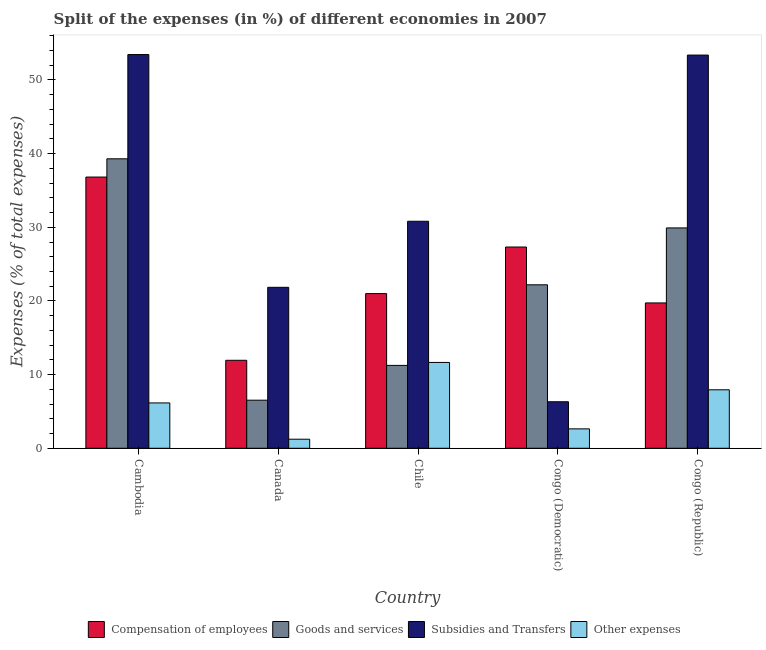How many groups of bars are there?
Make the answer very short. 5. Are the number of bars on each tick of the X-axis equal?
Provide a short and direct response. Yes. How many bars are there on the 4th tick from the left?
Your answer should be compact. 4. What is the label of the 5th group of bars from the left?
Ensure brevity in your answer.  Congo (Republic). In how many cases, is the number of bars for a given country not equal to the number of legend labels?
Your answer should be very brief. 0. What is the percentage of amount spent on subsidies in Congo (Democratic)?
Offer a terse response. 6.32. Across all countries, what is the maximum percentage of amount spent on other expenses?
Ensure brevity in your answer.  11.65. Across all countries, what is the minimum percentage of amount spent on goods and services?
Provide a short and direct response. 6.53. In which country was the percentage of amount spent on subsidies maximum?
Give a very brief answer. Cambodia. What is the total percentage of amount spent on compensation of employees in the graph?
Make the answer very short. 116.82. What is the difference between the percentage of amount spent on compensation of employees in Cambodia and that in Canada?
Your response must be concise. 24.88. What is the difference between the percentage of amount spent on subsidies in Cambodia and the percentage of amount spent on compensation of employees in Congo (Republic)?
Your answer should be very brief. 33.72. What is the average percentage of amount spent on compensation of employees per country?
Keep it short and to the point. 23.36. What is the difference between the percentage of amount spent on other expenses and percentage of amount spent on compensation of employees in Chile?
Keep it short and to the point. -9.35. What is the ratio of the percentage of amount spent on other expenses in Chile to that in Congo (Republic)?
Your response must be concise. 1.47. What is the difference between the highest and the second highest percentage of amount spent on goods and services?
Offer a terse response. 9.38. What is the difference between the highest and the lowest percentage of amount spent on compensation of employees?
Your answer should be very brief. 24.88. Is the sum of the percentage of amount spent on compensation of employees in Congo (Democratic) and Congo (Republic) greater than the maximum percentage of amount spent on subsidies across all countries?
Keep it short and to the point. No. Is it the case that in every country, the sum of the percentage of amount spent on goods and services and percentage of amount spent on subsidies is greater than the sum of percentage of amount spent on compensation of employees and percentage of amount spent on other expenses?
Make the answer very short. No. What does the 1st bar from the left in Congo (Democratic) represents?
Keep it short and to the point. Compensation of employees. What does the 2nd bar from the right in Cambodia represents?
Provide a short and direct response. Subsidies and Transfers. How many bars are there?
Provide a short and direct response. 20. How many countries are there in the graph?
Your answer should be compact. 5. Are the values on the major ticks of Y-axis written in scientific E-notation?
Your answer should be compact. No. How many legend labels are there?
Make the answer very short. 4. How are the legend labels stacked?
Your answer should be very brief. Horizontal. What is the title of the graph?
Your response must be concise. Split of the expenses (in %) of different economies in 2007. What is the label or title of the X-axis?
Your answer should be compact. Country. What is the label or title of the Y-axis?
Keep it short and to the point. Expenses (% of total expenses). What is the Expenses (% of total expenses) of Compensation of employees in Cambodia?
Offer a terse response. 36.82. What is the Expenses (% of total expenses) in Goods and services in Cambodia?
Ensure brevity in your answer.  39.3. What is the Expenses (% of total expenses) of Subsidies and Transfers in Cambodia?
Your answer should be compact. 53.45. What is the Expenses (% of total expenses) in Other expenses in Cambodia?
Your response must be concise. 6.16. What is the Expenses (% of total expenses) of Compensation of employees in Canada?
Provide a short and direct response. 11.95. What is the Expenses (% of total expenses) of Goods and services in Canada?
Your answer should be very brief. 6.53. What is the Expenses (% of total expenses) of Subsidies and Transfers in Canada?
Give a very brief answer. 21.85. What is the Expenses (% of total expenses) of Other expenses in Canada?
Offer a terse response. 1.23. What is the Expenses (% of total expenses) of Compensation of employees in Chile?
Ensure brevity in your answer.  21. What is the Expenses (% of total expenses) of Goods and services in Chile?
Offer a terse response. 11.25. What is the Expenses (% of total expenses) of Subsidies and Transfers in Chile?
Ensure brevity in your answer.  30.82. What is the Expenses (% of total expenses) of Other expenses in Chile?
Offer a terse response. 11.65. What is the Expenses (% of total expenses) in Compensation of employees in Congo (Democratic)?
Offer a very short reply. 27.32. What is the Expenses (% of total expenses) in Goods and services in Congo (Democratic)?
Make the answer very short. 22.19. What is the Expenses (% of total expenses) of Subsidies and Transfers in Congo (Democratic)?
Your answer should be compact. 6.32. What is the Expenses (% of total expenses) of Other expenses in Congo (Democratic)?
Offer a very short reply. 2.64. What is the Expenses (% of total expenses) of Compensation of employees in Congo (Republic)?
Your response must be concise. 19.73. What is the Expenses (% of total expenses) in Goods and services in Congo (Republic)?
Give a very brief answer. 29.92. What is the Expenses (% of total expenses) of Subsidies and Transfers in Congo (Republic)?
Make the answer very short. 53.38. What is the Expenses (% of total expenses) in Other expenses in Congo (Republic)?
Your answer should be compact. 7.94. Across all countries, what is the maximum Expenses (% of total expenses) of Compensation of employees?
Your response must be concise. 36.82. Across all countries, what is the maximum Expenses (% of total expenses) of Goods and services?
Make the answer very short. 39.3. Across all countries, what is the maximum Expenses (% of total expenses) of Subsidies and Transfers?
Your response must be concise. 53.45. Across all countries, what is the maximum Expenses (% of total expenses) of Other expenses?
Your response must be concise. 11.65. Across all countries, what is the minimum Expenses (% of total expenses) of Compensation of employees?
Provide a succinct answer. 11.95. Across all countries, what is the minimum Expenses (% of total expenses) in Goods and services?
Offer a very short reply. 6.53. Across all countries, what is the minimum Expenses (% of total expenses) in Subsidies and Transfers?
Give a very brief answer. 6.32. Across all countries, what is the minimum Expenses (% of total expenses) in Other expenses?
Give a very brief answer. 1.23. What is the total Expenses (% of total expenses) in Compensation of employees in the graph?
Your answer should be compact. 116.82. What is the total Expenses (% of total expenses) of Goods and services in the graph?
Make the answer very short. 109.19. What is the total Expenses (% of total expenses) in Subsidies and Transfers in the graph?
Your response must be concise. 165.83. What is the total Expenses (% of total expenses) of Other expenses in the graph?
Your answer should be very brief. 29.62. What is the difference between the Expenses (% of total expenses) in Compensation of employees in Cambodia and that in Canada?
Your answer should be very brief. 24.88. What is the difference between the Expenses (% of total expenses) of Goods and services in Cambodia and that in Canada?
Provide a succinct answer. 32.77. What is the difference between the Expenses (% of total expenses) of Subsidies and Transfers in Cambodia and that in Canada?
Give a very brief answer. 31.6. What is the difference between the Expenses (% of total expenses) in Other expenses in Cambodia and that in Canada?
Provide a short and direct response. 4.92. What is the difference between the Expenses (% of total expenses) of Compensation of employees in Cambodia and that in Chile?
Keep it short and to the point. 15.82. What is the difference between the Expenses (% of total expenses) in Goods and services in Cambodia and that in Chile?
Offer a terse response. 28.05. What is the difference between the Expenses (% of total expenses) of Subsidies and Transfers in Cambodia and that in Chile?
Your answer should be very brief. 22.63. What is the difference between the Expenses (% of total expenses) in Other expenses in Cambodia and that in Chile?
Give a very brief answer. -5.5. What is the difference between the Expenses (% of total expenses) in Compensation of employees in Cambodia and that in Congo (Democratic)?
Ensure brevity in your answer.  9.5. What is the difference between the Expenses (% of total expenses) of Goods and services in Cambodia and that in Congo (Democratic)?
Your answer should be compact. 17.11. What is the difference between the Expenses (% of total expenses) of Subsidies and Transfers in Cambodia and that in Congo (Democratic)?
Offer a very short reply. 47.14. What is the difference between the Expenses (% of total expenses) of Other expenses in Cambodia and that in Congo (Democratic)?
Make the answer very short. 3.52. What is the difference between the Expenses (% of total expenses) in Compensation of employees in Cambodia and that in Congo (Republic)?
Your response must be concise. 17.09. What is the difference between the Expenses (% of total expenses) in Goods and services in Cambodia and that in Congo (Republic)?
Your response must be concise. 9.38. What is the difference between the Expenses (% of total expenses) in Subsidies and Transfers in Cambodia and that in Congo (Republic)?
Your answer should be compact. 0.07. What is the difference between the Expenses (% of total expenses) in Other expenses in Cambodia and that in Congo (Republic)?
Provide a short and direct response. -1.78. What is the difference between the Expenses (% of total expenses) of Compensation of employees in Canada and that in Chile?
Ensure brevity in your answer.  -9.05. What is the difference between the Expenses (% of total expenses) in Goods and services in Canada and that in Chile?
Keep it short and to the point. -4.73. What is the difference between the Expenses (% of total expenses) of Subsidies and Transfers in Canada and that in Chile?
Offer a very short reply. -8.97. What is the difference between the Expenses (% of total expenses) in Other expenses in Canada and that in Chile?
Provide a succinct answer. -10.42. What is the difference between the Expenses (% of total expenses) of Compensation of employees in Canada and that in Congo (Democratic)?
Offer a terse response. -15.38. What is the difference between the Expenses (% of total expenses) in Goods and services in Canada and that in Congo (Democratic)?
Your answer should be very brief. -15.67. What is the difference between the Expenses (% of total expenses) of Subsidies and Transfers in Canada and that in Congo (Democratic)?
Provide a short and direct response. 15.54. What is the difference between the Expenses (% of total expenses) of Other expenses in Canada and that in Congo (Democratic)?
Provide a succinct answer. -1.4. What is the difference between the Expenses (% of total expenses) of Compensation of employees in Canada and that in Congo (Republic)?
Provide a succinct answer. -7.79. What is the difference between the Expenses (% of total expenses) in Goods and services in Canada and that in Congo (Republic)?
Make the answer very short. -23.39. What is the difference between the Expenses (% of total expenses) of Subsidies and Transfers in Canada and that in Congo (Republic)?
Offer a terse response. -31.53. What is the difference between the Expenses (% of total expenses) of Other expenses in Canada and that in Congo (Republic)?
Ensure brevity in your answer.  -6.71. What is the difference between the Expenses (% of total expenses) in Compensation of employees in Chile and that in Congo (Democratic)?
Keep it short and to the point. -6.32. What is the difference between the Expenses (% of total expenses) of Goods and services in Chile and that in Congo (Democratic)?
Make the answer very short. -10.94. What is the difference between the Expenses (% of total expenses) of Subsidies and Transfers in Chile and that in Congo (Democratic)?
Offer a very short reply. 24.5. What is the difference between the Expenses (% of total expenses) in Other expenses in Chile and that in Congo (Democratic)?
Provide a short and direct response. 9.02. What is the difference between the Expenses (% of total expenses) in Compensation of employees in Chile and that in Congo (Republic)?
Your response must be concise. 1.27. What is the difference between the Expenses (% of total expenses) in Goods and services in Chile and that in Congo (Republic)?
Ensure brevity in your answer.  -18.67. What is the difference between the Expenses (% of total expenses) of Subsidies and Transfers in Chile and that in Congo (Republic)?
Your answer should be compact. -22.56. What is the difference between the Expenses (% of total expenses) in Other expenses in Chile and that in Congo (Republic)?
Ensure brevity in your answer.  3.71. What is the difference between the Expenses (% of total expenses) of Compensation of employees in Congo (Democratic) and that in Congo (Republic)?
Provide a succinct answer. 7.59. What is the difference between the Expenses (% of total expenses) in Goods and services in Congo (Democratic) and that in Congo (Republic)?
Your answer should be very brief. -7.72. What is the difference between the Expenses (% of total expenses) of Subsidies and Transfers in Congo (Democratic) and that in Congo (Republic)?
Your answer should be very brief. -47.07. What is the difference between the Expenses (% of total expenses) in Other expenses in Congo (Democratic) and that in Congo (Republic)?
Keep it short and to the point. -5.3. What is the difference between the Expenses (% of total expenses) of Compensation of employees in Cambodia and the Expenses (% of total expenses) of Goods and services in Canada?
Make the answer very short. 30.29. What is the difference between the Expenses (% of total expenses) in Compensation of employees in Cambodia and the Expenses (% of total expenses) in Subsidies and Transfers in Canada?
Provide a succinct answer. 14.97. What is the difference between the Expenses (% of total expenses) in Compensation of employees in Cambodia and the Expenses (% of total expenses) in Other expenses in Canada?
Offer a very short reply. 35.59. What is the difference between the Expenses (% of total expenses) of Goods and services in Cambodia and the Expenses (% of total expenses) of Subsidies and Transfers in Canada?
Your answer should be compact. 17.45. What is the difference between the Expenses (% of total expenses) of Goods and services in Cambodia and the Expenses (% of total expenses) of Other expenses in Canada?
Make the answer very short. 38.07. What is the difference between the Expenses (% of total expenses) in Subsidies and Transfers in Cambodia and the Expenses (% of total expenses) in Other expenses in Canada?
Provide a short and direct response. 52.22. What is the difference between the Expenses (% of total expenses) of Compensation of employees in Cambodia and the Expenses (% of total expenses) of Goods and services in Chile?
Provide a short and direct response. 25.57. What is the difference between the Expenses (% of total expenses) in Compensation of employees in Cambodia and the Expenses (% of total expenses) in Subsidies and Transfers in Chile?
Provide a short and direct response. 6. What is the difference between the Expenses (% of total expenses) in Compensation of employees in Cambodia and the Expenses (% of total expenses) in Other expenses in Chile?
Your answer should be compact. 25.17. What is the difference between the Expenses (% of total expenses) in Goods and services in Cambodia and the Expenses (% of total expenses) in Subsidies and Transfers in Chile?
Offer a very short reply. 8.48. What is the difference between the Expenses (% of total expenses) of Goods and services in Cambodia and the Expenses (% of total expenses) of Other expenses in Chile?
Ensure brevity in your answer.  27.65. What is the difference between the Expenses (% of total expenses) in Subsidies and Transfers in Cambodia and the Expenses (% of total expenses) in Other expenses in Chile?
Provide a succinct answer. 41.8. What is the difference between the Expenses (% of total expenses) in Compensation of employees in Cambodia and the Expenses (% of total expenses) in Goods and services in Congo (Democratic)?
Provide a short and direct response. 14.63. What is the difference between the Expenses (% of total expenses) of Compensation of employees in Cambodia and the Expenses (% of total expenses) of Subsidies and Transfers in Congo (Democratic)?
Keep it short and to the point. 30.5. What is the difference between the Expenses (% of total expenses) of Compensation of employees in Cambodia and the Expenses (% of total expenses) of Other expenses in Congo (Democratic)?
Your response must be concise. 34.19. What is the difference between the Expenses (% of total expenses) in Goods and services in Cambodia and the Expenses (% of total expenses) in Subsidies and Transfers in Congo (Democratic)?
Give a very brief answer. 32.98. What is the difference between the Expenses (% of total expenses) in Goods and services in Cambodia and the Expenses (% of total expenses) in Other expenses in Congo (Democratic)?
Offer a very short reply. 36.66. What is the difference between the Expenses (% of total expenses) of Subsidies and Transfers in Cambodia and the Expenses (% of total expenses) of Other expenses in Congo (Democratic)?
Offer a terse response. 50.82. What is the difference between the Expenses (% of total expenses) of Compensation of employees in Cambodia and the Expenses (% of total expenses) of Goods and services in Congo (Republic)?
Your answer should be compact. 6.9. What is the difference between the Expenses (% of total expenses) of Compensation of employees in Cambodia and the Expenses (% of total expenses) of Subsidies and Transfers in Congo (Republic)?
Your answer should be very brief. -16.56. What is the difference between the Expenses (% of total expenses) of Compensation of employees in Cambodia and the Expenses (% of total expenses) of Other expenses in Congo (Republic)?
Give a very brief answer. 28.88. What is the difference between the Expenses (% of total expenses) of Goods and services in Cambodia and the Expenses (% of total expenses) of Subsidies and Transfers in Congo (Republic)?
Your response must be concise. -14.08. What is the difference between the Expenses (% of total expenses) in Goods and services in Cambodia and the Expenses (% of total expenses) in Other expenses in Congo (Republic)?
Provide a succinct answer. 31.36. What is the difference between the Expenses (% of total expenses) in Subsidies and Transfers in Cambodia and the Expenses (% of total expenses) in Other expenses in Congo (Republic)?
Provide a short and direct response. 45.51. What is the difference between the Expenses (% of total expenses) in Compensation of employees in Canada and the Expenses (% of total expenses) in Goods and services in Chile?
Ensure brevity in your answer.  0.69. What is the difference between the Expenses (% of total expenses) in Compensation of employees in Canada and the Expenses (% of total expenses) in Subsidies and Transfers in Chile?
Provide a short and direct response. -18.88. What is the difference between the Expenses (% of total expenses) of Compensation of employees in Canada and the Expenses (% of total expenses) of Other expenses in Chile?
Your answer should be compact. 0.29. What is the difference between the Expenses (% of total expenses) of Goods and services in Canada and the Expenses (% of total expenses) of Subsidies and Transfers in Chile?
Provide a short and direct response. -24.29. What is the difference between the Expenses (% of total expenses) of Goods and services in Canada and the Expenses (% of total expenses) of Other expenses in Chile?
Make the answer very short. -5.12. What is the difference between the Expenses (% of total expenses) in Subsidies and Transfers in Canada and the Expenses (% of total expenses) in Other expenses in Chile?
Keep it short and to the point. 10.2. What is the difference between the Expenses (% of total expenses) of Compensation of employees in Canada and the Expenses (% of total expenses) of Goods and services in Congo (Democratic)?
Provide a short and direct response. -10.25. What is the difference between the Expenses (% of total expenses) in Compensation of employees in Canada and the Expenses (% of total expenses) in Subsidies and Transfers in Congo (Democratic)?
Ensure brevity in your answer.  5.63. What is the difference between the Expenses (% of total expenses) in Compensation of employees in Canada and the Expenses (% of total expenses) in Other expenses in Congo (Democratic)?
Your answer should be compact. 9.31. What is the difference between the Expenses (% of total expenses) of Goods and services in Canada and the Expenses (% of total expenses) of Subsidies and Transfers in Congo (Democratic)?
Offer a terse response. 0.21. What is the difference between the Expenses (% of total expenses) of Goods and services in Canada and the Expenses (% of total expenses) of Other expenses in Congo (Democratic)?
Offer a very short reply. 3.89. What is the difference between the Expenses (% of total expenses) in Subsidies and Transfers in Canada and the Expenses (% of total expenses) in Other expenses in Congo (Democratic)?
Offer a terse response. 19.22. What is the difference between the Expenses (% of total expenses) of Compensation of employees in Canada and the Expenses (% of total expenses) of Goods and services in Congo (Republic)?
Provide a succinct answer. -17.97. What is the difference between the Expenses (% of total expenses) of Compensation of employees in Canada and the Expenses (% of total expenses) of Subsidies and Transfers in Congo (Republic)?
Offer a very short reply. -41.44. What is the difference between the Expenses (% of total expenses) in Compensation of employees in Canada and the Expenses (% of total expenses) in Other expenses in Congo (Republic)?
Make the answer very short. 4.01. What is the difference between the Expenses (% of total expenses) of Goods and services in Canada and the Expenses (% of total expenses) of Subsidies and Transfers in Congo (Republic)?
Ensure brevity in your answer.  -46.86. What is the difference between the Expenses (% of total expenses) in Goods and services in Canada and the Expenses (% of total expenses) in Other expenses in Congo (Republic)?
Give a very brief answer. -1.41. What is the difference between the Expenses (% of total expenses) in Subsidies and Transfers in Canada and the Expenses (% of total expenses) in Other expenses in Congo (Republic)?
Keep it short and to the point. 13.91. What is the difference between the Expenses (% of total expenses) in Compensation of employees in Chile and the Expenses (% of total expenses) in Goods and services in Congo (Democratic)?
Your answer should be very brief. -1.19. What is the difference between the Expenses (% of total expenses) of Compensation of employees in Chile and the Expenses (% of total expenses) of Subsidies and Transfers in Congo (Democratic)?
Offer a terse response. 14.68. What is the difference between the Expenses (% of total expenses) of Compensation of employees in Chile and the Expenses (% of total expenses) of Other expenses in Congo (Democratic)?
Offer a very short reply. 18.36. What is the difference between the Expenses (% of total expenses) of Goods and services in Chile and the Expenses (% of total expenses) of Subsidies and Transfers in Congo (Democratic)?
Offer a terse response. 4.94. What is the difference between the Expenses (% of total expenses) in Goods and services in Chile and the Expenses (% of total expenses) in Other expenses in Congo (Democratic)?
Offer a terse response. 8.62. What is the difference between the Expenses (% of total expenses) in Subsidies and Transfers in Chile and the Expenses (% of total expenses) in Other expenses in Congo (Democratic)?
Offer a terse response. 28.19. What is the difference between the Expenses (% of total expenses) of Compensation of employees in Chile and the Expenses (% of total expenses) of Goods and services in Congo (Republic)?
Make the answer very short. -8.92. What is the difference between the Expenses (% of total expenses) of Compensation of employees in Chile and the Expenses (% of total expenses) of Subsidies and Transfers in Congo (Republic)?
Ensure brevity in your answer.  -32.38. What is the difference between the Expenses (% of total expenses) of Compensation of employees in Chile and the Expenses (% of total expenses) of Other expenses in Congo (Republic)?
Offer a very short reply. 13.06. What is the difference between the Expenses (% of total expenses) in Goods and services in Chile and the Expenses (% of total expenses) in Subsidies and Transfers in Congo (Republic)?
Your response must be concise. -42.13. What is the difference between the Expenses (% of total expenses) of Goods and services in Chile and the Expenses (% of total expenses) of Other expenses in Congo (Republic)?
Provide a short and direct response. 3.31. What is the difference between the Expenses (% of total expenses) in Subsidies and Transfers in Chile and the Expenses (% of total expenses) in Other expenses in Congo (Republic)?
Make the answer very short. 22.88. What is the difference between the Expenses (% of total expenses) of Compensation of employees in Congo (Democratic) and the Expenses (% of total expenses) of Goods and services in Congo (Republic)?
Provide a short and direct response. -2.6. What is the difference between the Expenses (% of total expenses) of Compensation of employees in Congo (Democratic) and the Expenses (% of total expenses) of Subsidies and Transfers in Congo (Republic)?
Your response must be concise. -26.06. What is the difference between the Expenses (% of total expenses) in Compensation of employees in Congo (Democratic) and the Expenses (% of total expenses) in Other expenses in Congo (Republic)?
Your answer should be very brief. 19.38. What is the difference between the Expenses (% of total expenses) of Goods and services in Congo (Democratic) and the Expenses (% of total expenses) of Subsidies and Transfers in Congo (Republic)?
Make the answer very short. -31.19. What is the difference between the Expenses (% of total expenses) in Goods and services in Congo (Democratic) and the Expenses (% of total expenses) in Other expenses in Congo (Republic)?
Ensure brevity in your answer.  14.25. What is the difference between the Expenses (% of total expenses) of Subsidies and Transfers in Congo (Democratic) and the Expenses (% of total expenses) of Other expenses in Congo (Republic)?
Your response must be concise. -1.62. What is the average Expenses (% of total expenses) of Compensation of employees per country?
Ensure brevity in your answer.  23.36. What is the average Expenses (% of total expenses) of Goods and services per country?
Make the answer very short. 21.84. What is the average Expenses (% of total expenses) of Subsidies and Transfers per country?
Your response must be concise. 33.17. What is the average Expenses (% of total expenses) in Other expenses per country?
Ensure brevity in your answer.  5.92. What is the difference between the Expenses (% of total expenses) of Compensation of employees and Expenses (% of total expenses) of Goods and services in Cambodia?
Make the answer very short. -2.48. What is the difference between the Expenses (% of total expenses) in Compensation of employees and Expenses (% of total expenses) in Subsidies and Transfers in Cambodia?
Offer a very short reply. -16.63. What is the difference between the Expenses (% of total expenses) in Compensation of employees and Expenses (% of total expenses) in Other expenses in Cambodia?
Offer a very short reply. 30.67. What is the difference between the Expenses (% of total expenses) of Goods and services and Expenses (% of total expenses) of Subsidies and Transfers in Cambodia?
Your answer should be very brief. -14.15. What is the difference between the Expenses (% of total expenses) of Goods and services and Expenses (% of total expenses) of Other expenses in Cambodia?
Your answer should be very brief. 33.14. What is the difference between the Expenses (% of total expenses) in Subsidies and Transfers and Expenses (% of total expenses) in Other expenses in Cambodia?
Provide a short and direct response. 47.3. What is the difference between the Expenses (% of total expenses) of Compensation of employees and Expenses (% of total expenses) of Goods and services in Canada?
Your answer should be compact. 5.42. What is the difference between the Expenses (% of total expenses) in Compensation of employees and Expenses (% of total expenses) in Subsidies and Transfers in Canada?
Ensure brevity in your answer.  -9.91. What is the difference between the Expenses (% of total expenses) in Compensation of employees and Expenses (% of total expenses) in Other expenses in Canada?
Keep it short and to the point. 10.71. What is the difference between the Expenses (% of total expenses) in Goods and services and Expenses (% of total expenses) in Subsidies and Transfers in Canada?
Provide a short and direct response. -15.33. What is the difference between the Expenses (% of total expenses) in Goods and services and Expenses (% of total expenses) in Other expenses in Canada?
Offer a terse response. 5.3. What is the difference between the Expenses (% of total expenses) of Subsidies and Transfers and Expenses (% of total expenses) of Other expenses in Canada?
Give a very brief answer. 20.62. What is the difference between the Expenses (% of total expenses) in Compensation of employees and Expenses (% of total expenses) in Goods and services in Chile?
Provide a short and direct response. 9.75. What is the difference between the Expenses (% of total expenses) in Compensation of employees and Expenses (% of total expenses) in Subsidies and Transfers in Chile?
Offer a very short reply. -9.82. What is the difference between the Expenses (% of total expenses) of Compensation of employees and Expenses (% of total expenses) of Other expenses in Chile?
Ensure brevity in your answer.  9.35. What is the difference between the Expenses (% of total expenses) of Goods and services and Expenses (% of total expenses) of Subsidies and Transfers in Chile?
Your answer should be very brief. -19.57. What is the difference between the Expenses (% of total expenses) in Goods and services and Expenses (% of total expenses) in Other expenses in Chile?
Provide a short and direct response. -0.4. What is the difference between the Expenses (% of total expenses) in Subsidies and Transfers and Expenses (% of total expenses) in Other expenses in Chile?
Keep it short and to the point. 19.17. What is the difference between the Expenses (% of total expenses) of Compensation of employees and Expenses (% of total expenses) of Goods and services in Congo (Democratic)?
Offer a very short reply. 5.13. What is the difference between the Expenses (% of total expenses) in Compensation of employees and Expenses (% of total expenses) in Subsidies and Transfers in Congo (Democratic)?
Provide a succinct answer. 21.01. What is the difference between the Expenses (% of total expenses) of Compensation of employees and Expenses (% of total expenses) of Other expenses in Congo (Democratic)?
Offer a very short reply. 24.69. What is the difference between the Expenses (% of total expenses) in Goods and services and Expenses (% of total expenses) in Subsidies and Transfers in Congo (Democratic)?
Ensure brevity in your answer.  15.88. What is the difference between the Expenses (% of total expenses) in Goods and services and Expenses (% of total expenses) in Other expenses in Congo (Democratic)?
Your response must be concise. 19.56. What is the difference between the Expenses (% of total expenses) in Subsidies and Transfers and Expenses (% of total expenses) in Other expenses in Congo (Democratic)?
Your answer should be very brief. 3.68. What is the difference between the Expenses (% of total expenses) of Compensation of employees and Expenses (% of total expenses) of Goods and services in Congo (Republic)?
Ensure brevity in your answer.  -10.18. What is the difference between the Expenses (% of total expenses) of Compensation of employees and Expenses (% of total expenses) of Subsidies and Transfers in Congo (Republic)?
Provide a short and direct response. -33.65. What is the difference between the Expenses (% of total expenses) in Compensation of employees and Expenses (% of total expenses) in Other expenses in Congo (Republic)?
Your response must be concise. 11.79. What is the difference between the Expenses (% of total expenses) of Goods and services and Expenses (% of total expenses) of Subsidies and Transfers in Congo (Republic)?
Offer a very short reply. -23.47. What is the difference between the Expenses (% of total expenses) in Goods and services and Expenses (% of total expenses) in Other expenses in Congo (Republic)?
Offer a terse response. 21.98. What is the difference between the Expenses (% of total expenses) of Subsidies and Transfers and Expenses (% of total expenses) of Other expenses in Congo (Republic)?
Your response must be concise. 45.44. What is the ratio of the Expenses (% of total expenses) in Compensation of employees in Cambodia to that in Canada?
Give a very brief answer. 3.08. What is the ratio of the Expenses (% of total expenses) in Goods and services in Cambodia to that in Canada?
Offer a very short reply. 6.02. What is the ratio of the Expenses (% of total expenses) in Subsidies and Transfers in Cambodia to that in Canada?
Your answer should be compact. 2.45. What is the ratio of the Expenses (% of total expenses) of Other expenses in Cambodia to that in Canada?
Give a very brief answer. 5. What is the ratio of the Expenses (% of total expenses) of Compensation of employees in Cambodia to that in Chile?
Your answer should be very brief. 1.75. What is the ratio of the Expenses (% of total expenses) in Goods and services in Cambodia to that in Chile?
Make the answer very short. 3.49. What is the ratio of the Expenses (% of total expenses) in Subsidies and Transfers in Cambodia to that in Chile?
Provide a short and direct response. 1.73. What is the ratio of the Expenses (% of total expenses) of Other expenses in Cambodia to that in Chile?
Provide a short and direct response. 0.53. What is the ratio of the Expenses (% of total expenses) of Compensation of employees in Cambodia to that in Congo (Democratic)?
Your response must be concise. 1.35. What is the ratio of the Expenses (% of total expenses) in Goods and services in Cambodia to that in Congo (Democratic)?
Your answer should be very brief. 1.77. What is the ratio of the Expenses (% of total expenses) in Subsidies and Transfers in Cambodia to that in Congo (Democratic)?
Give a very brief answer. 8.46. What is the ratio of the Expenses (% of total expenses) in Other expenses in Cambodia to that in Congo (Democratic)?
Give a very brief answer. 2.34. What is the ratio of the Expenses (% of total expenses) of Compensation of employees in Cambodia to that in Congo (Republic)?
Your response must be concise. 1.87. What is the ratio of the Expenses (% of total expenses) of Goods and services in Cambodia to that in Congo (Republic)?
Provide a short and direct response. 1.31. What is the ratio of the Expenses (% of total expenses) in Subsidies and Transfers in Cambodia to that in Congo (Republic)?
Offer a very short reply. 1. What is the ratio of the Expenses (% of total expenses) in Other expenses in Cambodia to that in Congo (Republic)?
Provide a succinct answer. 0.78. What is the ratio of the Expenses (% of total expenses) in Compensation of employees in Canada to that in Chile?
Keep it short and to the point. 0.57. What is the ratio of the Expenses (% of total expenses) of Goods and services in Canada to that in Chile?
Your response must be concise. 0.58. What is the ratio of the Expenses (% of total expenses) in Subsidies and Transfers in Canada to that in Chile?
Ensure brevity in your answer.  0.71. What is the ratio of the Expenses (% of total expenses) in Other expenses in Canada to that in Chile?
Offer a very short reply. 0.11. What is the ratio of the Expenses (% of total expenses) in Compensation of employees in Canada to that in Congo (Democratic)?
Offer a very short reply. 0.44. What is the ratio of the Expenses (% of total expenses) of Goods and services in Canada to that in Congo (Democratic)?
Your response must be concise. 0.29. What is the ratio of the Expenses (% of total expenses) of Subsidies and Transfers in Canada to that in Congo (Democratic)?
Your response must be concise. 3.46. What is the ratio of the Expenses (% of total expenses) of Other expenses in Canada to that in Congo (Democratic)?
Your response must be concise. 0.47. What is the ratio of the Expenses (% of total expenses) in Compensation of employees in Canada to that in Congo (Republic)?
Your response must be concise. 0.61. What is the ratio of the Expenses (% of total expenses) of Goods and services in Canada to that in Congo (Republic)?
Your answer should be compact. 0.22. What is the ratio of the Expenses (% of total expenses) in Subsidies and Transfers in Canada to that in Congo (Republic)?
Give a very brief answer. 0.41. What is the ratio of the Expenses (% of total expenses) of Other expenses in Canada to that in Congo (Republic)?
Your response must be concise. 0.16. What is the ratio of the Expenses (% of total expenses) in Compensation of employees in Chile to that in Congo (Democratic)?
Provide a short and direct response. 0.77. What is the ratio of the Expenses (% of total expenses) in Goods and services in Chile to that in Congo (Democratic)?
Provide a short and direct response. 0.51. What is the ratio of the Expenses (% of total expenses) of Subsidies and Transfers in Chile to that in Congo (Democratic)?
Your answer should be very brief. 4.88. What is the ratio of the Expenses (% of total expenses) of Other expenses in Chile to that in Congo (Democratic)?
Provide a succinct answer. 4.42. What is the ratio of the Expenses (% of total expenses) of Compensation of employees in Chile to that in Congo (Republic)?
Provide a short and direct response. 1.06. What is the ratio of the Expenses (% of total expenses) of Goods and services in Chile to that in Congo (Republic)?
Your answer should be compact. 0.38. What is the ratio of the Expenses (% of total expenses) in Subsidies and Transfers in Chile to that in Congo (Republic)?
Provide a succinct answer. 0.58. What is the ratio of the Expenses (% of total expenses) in Other expenses in Chile to that in Congo (Republic)?
Provide a short and direct response. 1.47. What is the ratio of the Expenses (% of total expenses) in Compensation of employees in Congo (Democratic) to that in Congo (Republic)?
Provide a short and direct response. 1.38. What is the ratio of the Expenses (% of total expenses) of Goods and services in Congo (Democratic) to that in Congo (Republic)?
Your response must be concise. 0.74. What is the ratio of the Expenses (% of total expenses) of Subsidies and Transfers in Congo (Democratic) to that in Congo (Republic)?
Ensure brevity in your answer.  0.12. What is the ratio of the Expenses (% of total expenses) of Other expenses in Congo (Democratic) to that in Congo (Republic)?
Keep it short and to the point. 0.33. What is the difference between the highest and the second highest Expenses (% of total expenses) of Compensation of employees?
Offer a terse response. 9.5. What is the difference between the highest and the second highest Expenses (% of total expenses) of Goods and services?
Make the answer very short. 9.38. What is the difference between the highest and the second highest Expenses (% of total expenses) of Subsidies and Transfers?
Offer a terse response. 0.07. What is the difference between the highest and the second highest Expenses (% of total expenses) of Other expenses?
Make the answer very short. 3.71. What is the difference between the highest and the lowest Expenses (% of total expenses) in Compensation of employees?
Give a very brief answer. 24.88. What is the difference between the highest and the lowest Expenses (% of total expenses) of Goods and services?
Your answer should be very brief. 32.77. What is the difference between the highest and the lowest Expenses (% of total expenses) of Subsidies and Transfers?
Your answer should be very brief. 47.14. What is the difference between the highest and the lowest Expenses (% of total expenses) in Other expenses?
Your answer should be compact. 10.42. 